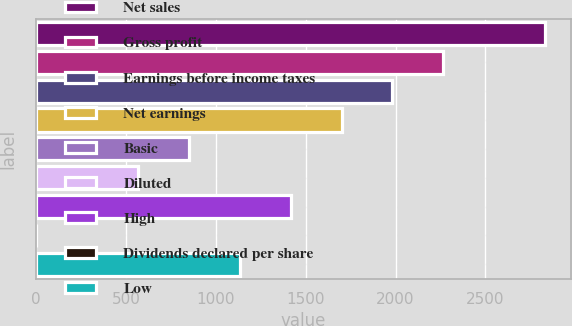Convert chart. <chart><loc_0><loc_0><loc_500><loc_500><bar_chart><fcel>Net sales<fcel>Gross profit<fcel>Earnings before income taxes<fcel>Net earnings<fcel>Basic<fcel>Diluted<fcel>High<fcel>Dividends declared per share<fcel>Low<nl><fcel>2833<fcel>2266.5<fcel>1983.23<fcel>1699.96<fcel>850.15<fcel>566.88<fcel>1416.69<fcel>0.34<fcel>1133.42<nl></chart> 